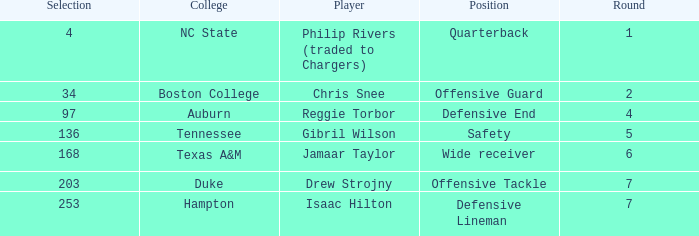Which Position has a Player of gibril wilson? Safety. 